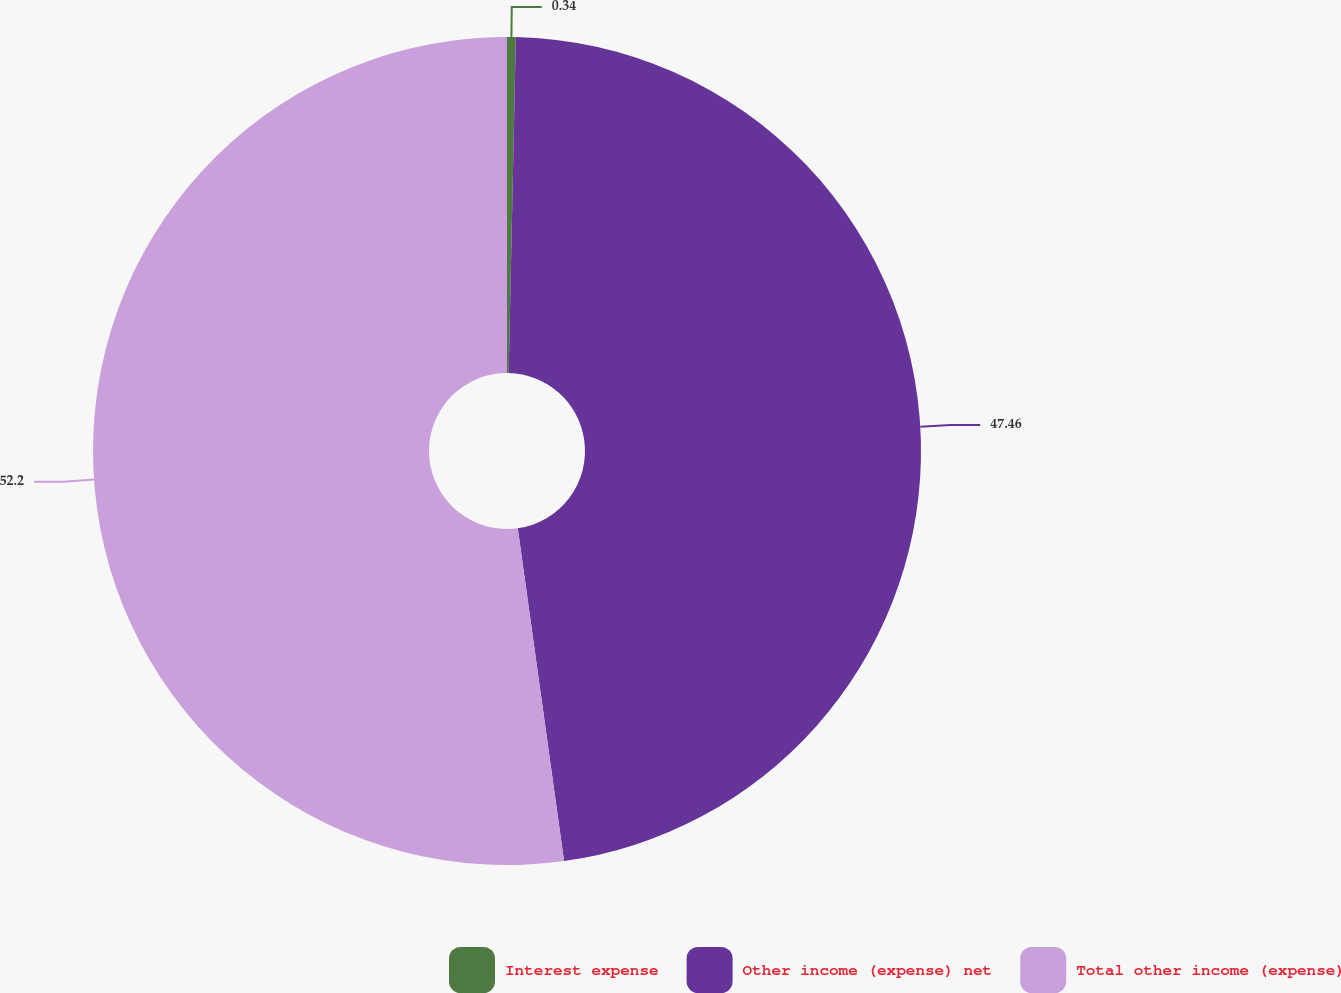Convert chart to OTSL. <chart><loc_0><loc_0><loc_500><loc_500><pie_chart><fcel>Interest expense<fcel>Other income (expense) net<fcel>Total other income (expense)<nl><fcel>0.34%<fcel>47.46%<fcel>52.2%<nl></chart> 